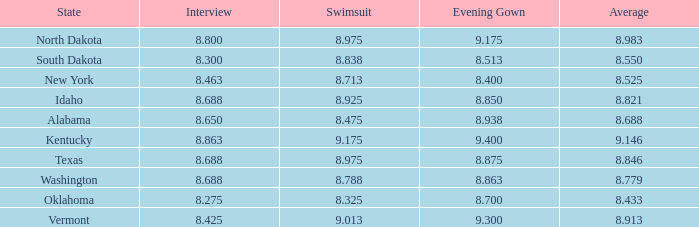Who had the lowest interview score from South Dakota with an evening gown less than 8.513? None. 